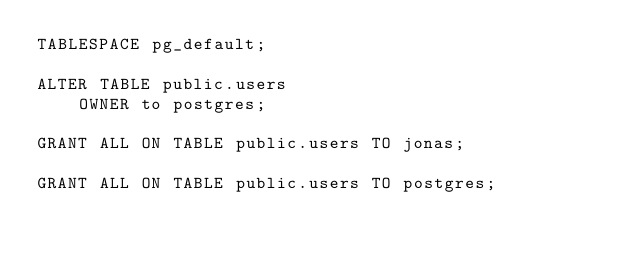Convert code to text. <code><loc_0><loc_0><loc_500><loc_500><_SQL_>TABLESPACE pg_default;

ALTER TABLE public.users
    OWNER to postgres;

GRANT ALL ON TABLE public.users TO jonas;

GRANT ALL ON TABLE public.users TO postgres;</code> 